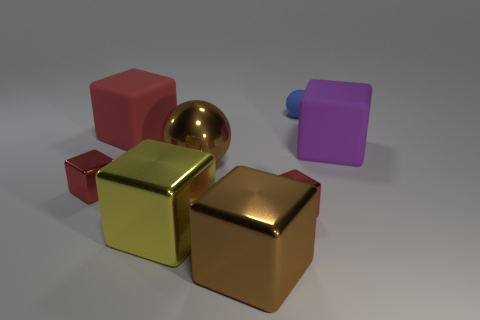How many red cubes must be subtracted to get 1 red cubes? 2 Subtract all yellow balls. How many red blocks are left? 3 Subtract all brown cubes. How many cubes are left? 5 Subtract all large purple blocks. How many blocks are left? 5 Subtract all brown cubes. Subtract all gray cylinders. How many cubes are left? 5 Add 1 big metal things. How many objects exist? 9 Subtract all blocks. How many objects are left? 2 Subtract all green metal objects. Subtract all blue spheres. How many objects are left? 7 Add 2 large objects. How many large objects are left? 7 Add 5 blue objects. How many blue objects exist? 6 